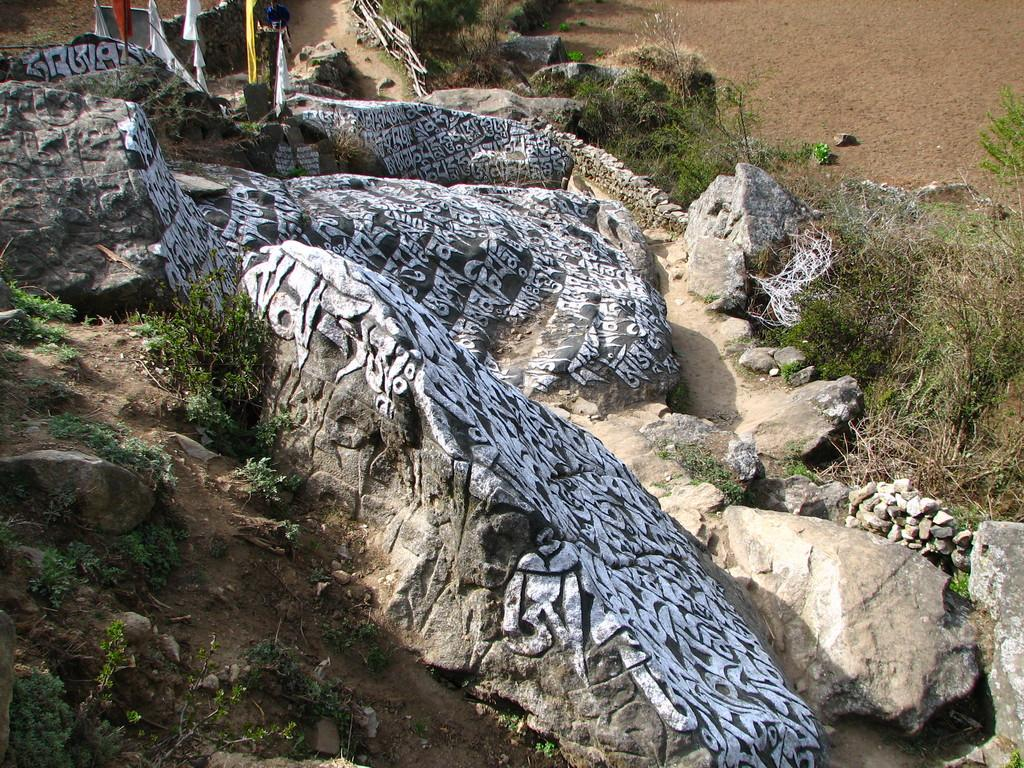What type of natural formation can be seen in the image? There are rocks in the image. Are there any markings or words on the rocks? Yes, there is text on the rocks. What type of vegetation is present at the bottom of the image? There are small plants at the bottom of the image. What type of ground cover is visible in the image? There is grass on the ground in the image. How many houses can be seen in the image? There are no houses present in the image. 